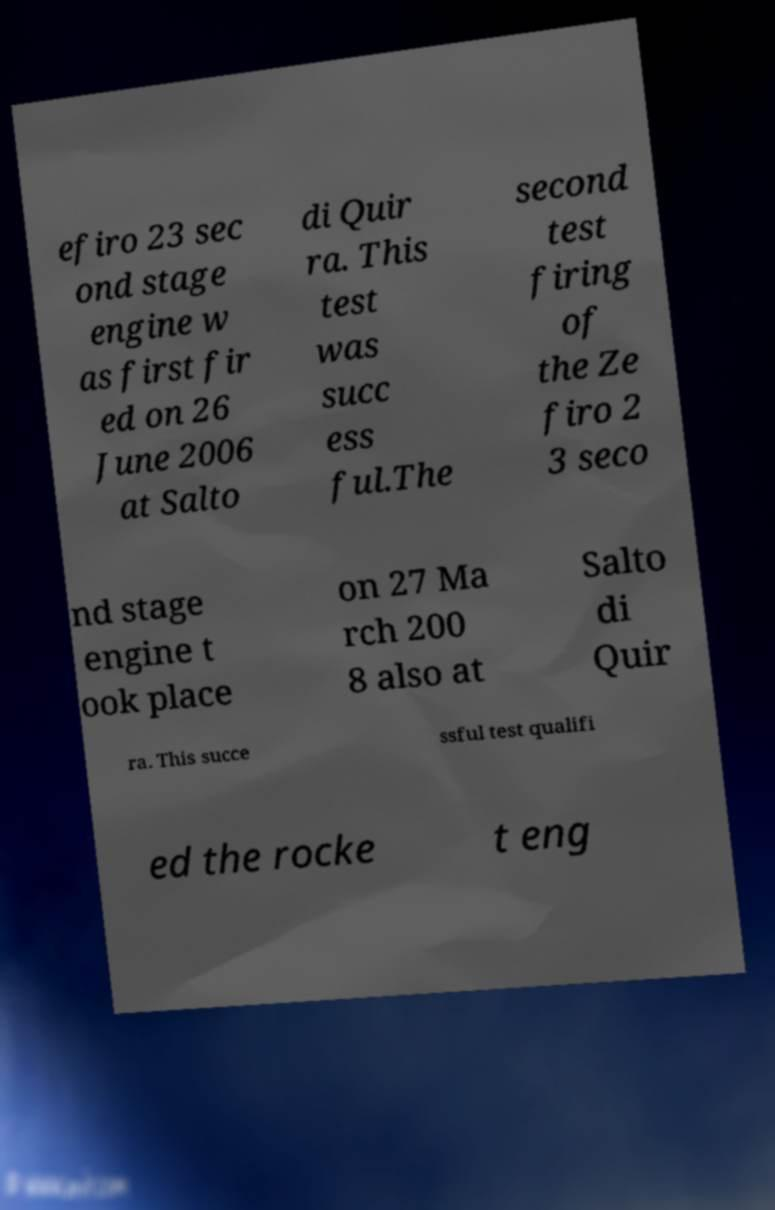Please read and relay the text visible in this image. What does it say? efiro 23 sec ond stage engine w as first fir ed on 26 June 2006 at Salto di Quir ra. This test was succ ess ful.The second test firing of the Ze firo 2 3 seco nd stage engine t ook place on 27 Ma rch 200 8 also at Salto di Quir ra. This succe ssful test qualifi ed the rocke t eng 